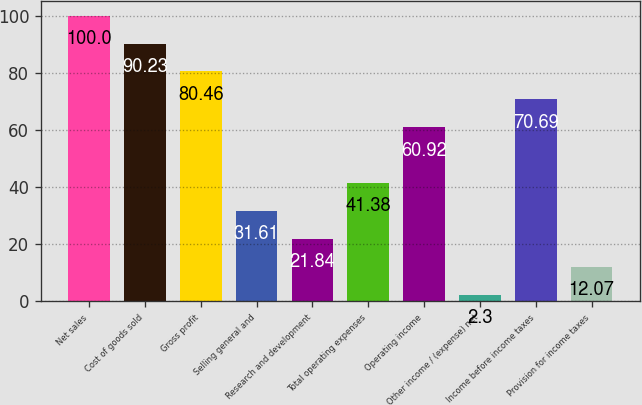<chart> <loc_0><loc_0><loc_500><loc_500><bar_chart><fcel>Net sales<fcel>Cost of goods sold<fcel>Gross profit<fcel>Selling general and<fcel>Research and development<fcel>Total operating expenses<fcel>Operating income<fcel>Other income / (expense) net<fcel>Income before income taxes<fcel>Provision for income taxes<nl><fcel>100<fcel>90.23<fcel>80.46<fcel>31.61<fcel>21.84<fcel>41.38<fcel>60.92<fcel>2.3<fcel>70.69<fcel>12.07<nl></chart> 